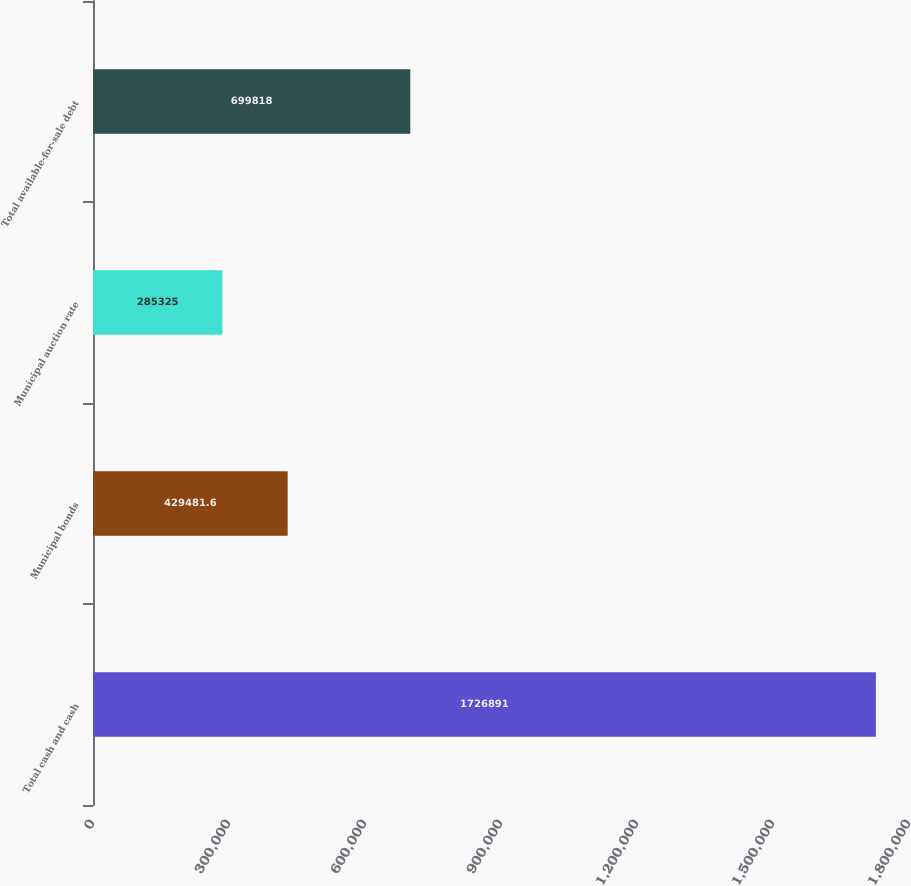<chart> <loc_0><loc_0><loc_500><loc_500><bar_chart><fcel>Total cash and cash<fcel>Municipal bonds<fcel>Municipal auction rate<fcel>Total available-for-sale debt<nl><fcel>1.72689e+06<fcel>429482<fcel>285325<fcel>699818<nl></chart> 